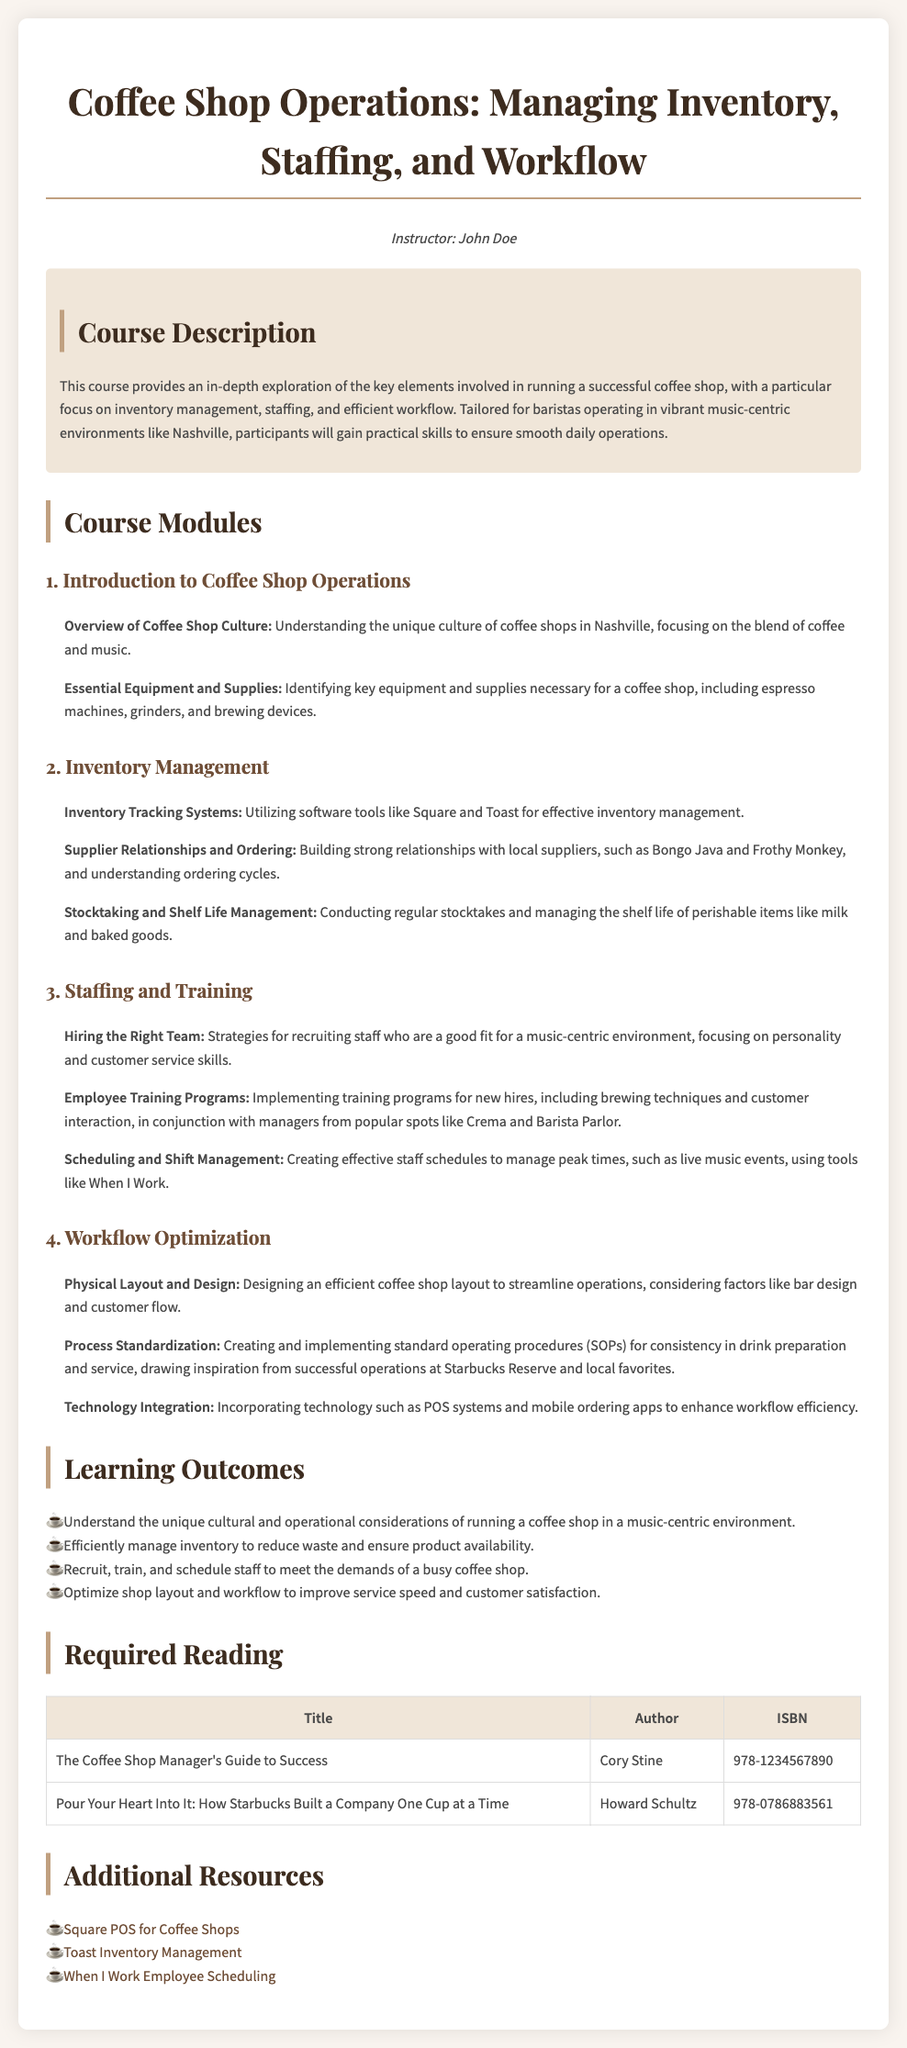what is the title of the syllabus? The title of the syllabus is indicated at the top of the document.
Answer: Coffee Shop Operations: Managing Inventory, Staffing, and Workflow who is the instructor for the course? The instructor's name is provided after the title.
Answer: John Doe what is one of the essential topics covered in Inventory Management? This information can be found in the Inventory Management module.
Answer: Supplier Relationships and Ordering how many modules are included in the syllabus? The document lists the number of modules under Course Modules.
Answer: Four what type of systems are mentioned for inventory tracking? The document specifies types of tools used for inventory management in the Inventory Management section.
Answer: Software tools like Square and Toast which coffee shop is mentioned as a supplier in the syllabus? The syllabus lists suppliers in the Inventory Management section.
Answer: Bongo Java what is one of the learning outcomes related to staffing? The learning outcomes list a specific staffing-related goal at the end of the document.
Answer: Recruit, train, and schedule staff to meet the demands of a busy coffee shop what is the first required reading title? The required reading section provides the titles of the books.
Answer: The Coffee Shop Manager's Guide to Success which scheduling tool is recommended in the syllabus? The additional resources section specifies tools for employee scheduling.
Answer: When I Work Employee Scheduling 